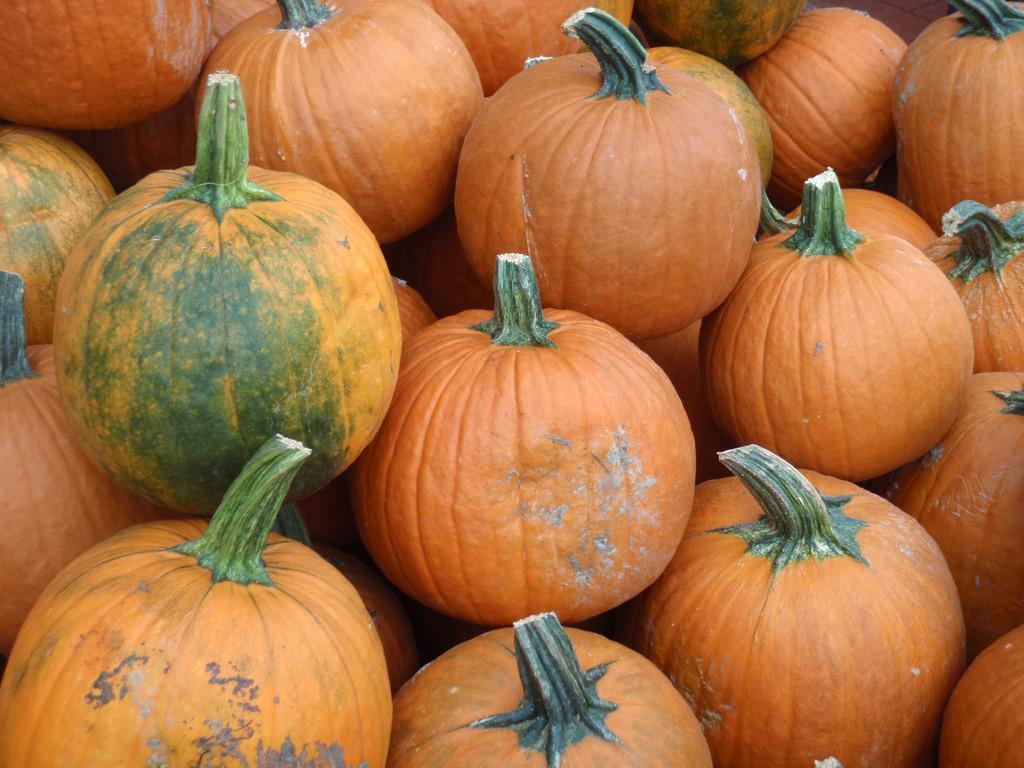Can you describe this image briefly? This picture contains many pumpkins which are in orange and green color. This picture might be clicked in the market. 